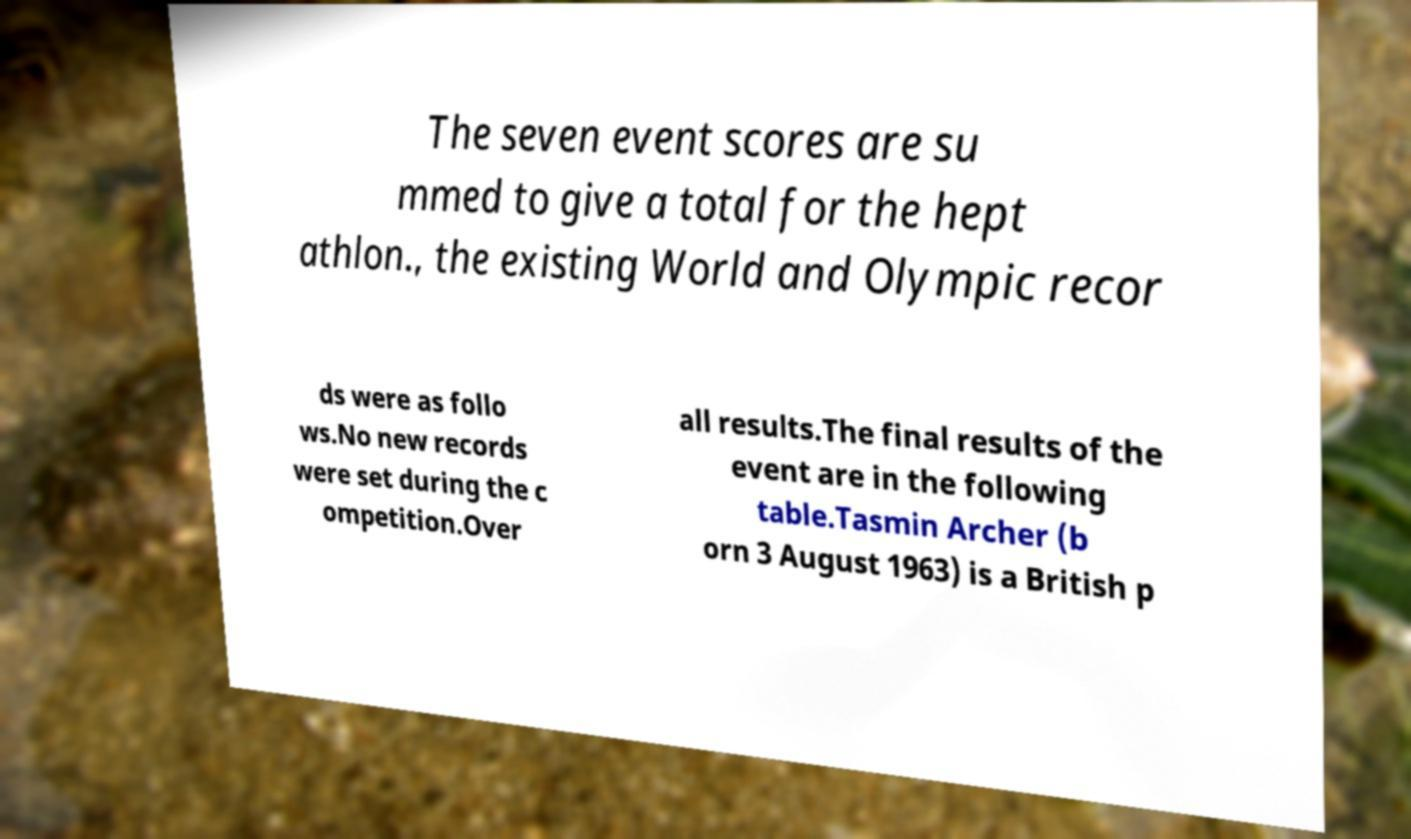Can you read and provide the text displayed in the image?This photo seems to have some interesting text. Can you extract and type it out for me? The seven event scores are su mmed to give a total for the hept athlon., the existing World and Olympic recor ds were as follo ws.No new records were set during the c ompetition.Over all results.The final results of the event are in the following table.Tasmin Archer (b orn 3 August 1963) is a British p 